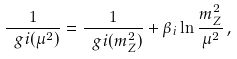<formula> <loc_0><loc_0><loc_500><loc_500>\frac { 1 } { \ g { i } ( \mu ^ { 2 } ) } = \frac { 1 } { \ g { i } ( m _ { Z } ^ { 2 } ) } + \beta _ { i } \ln \frac { m _ { Z } ^ { 2 } } { \mu ^ { 2 } } \, ,</formula> 